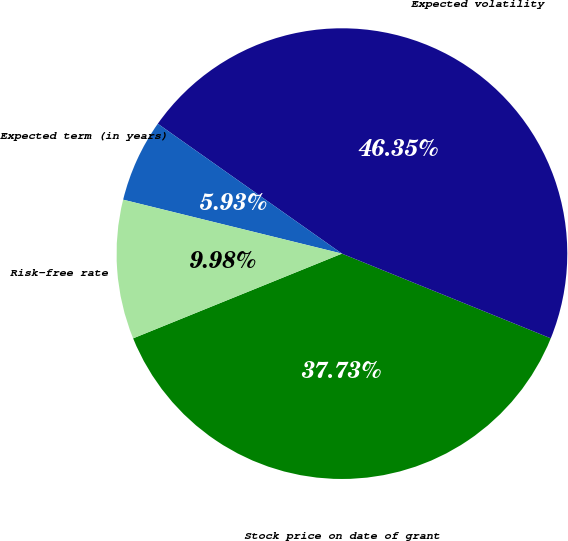Convert chart. <chart><loc_0><loc_0><loc_500><loc_500><pie_chart><fcel>Stock price on date of grant<fcel>Expected volatility<fcel>Expected term (in years)<fcel>Risk-free rate<nl><fcel>37.73%<fcel>46.35%<fcel>5.93%<fcel>9.98%<nl></chart> 